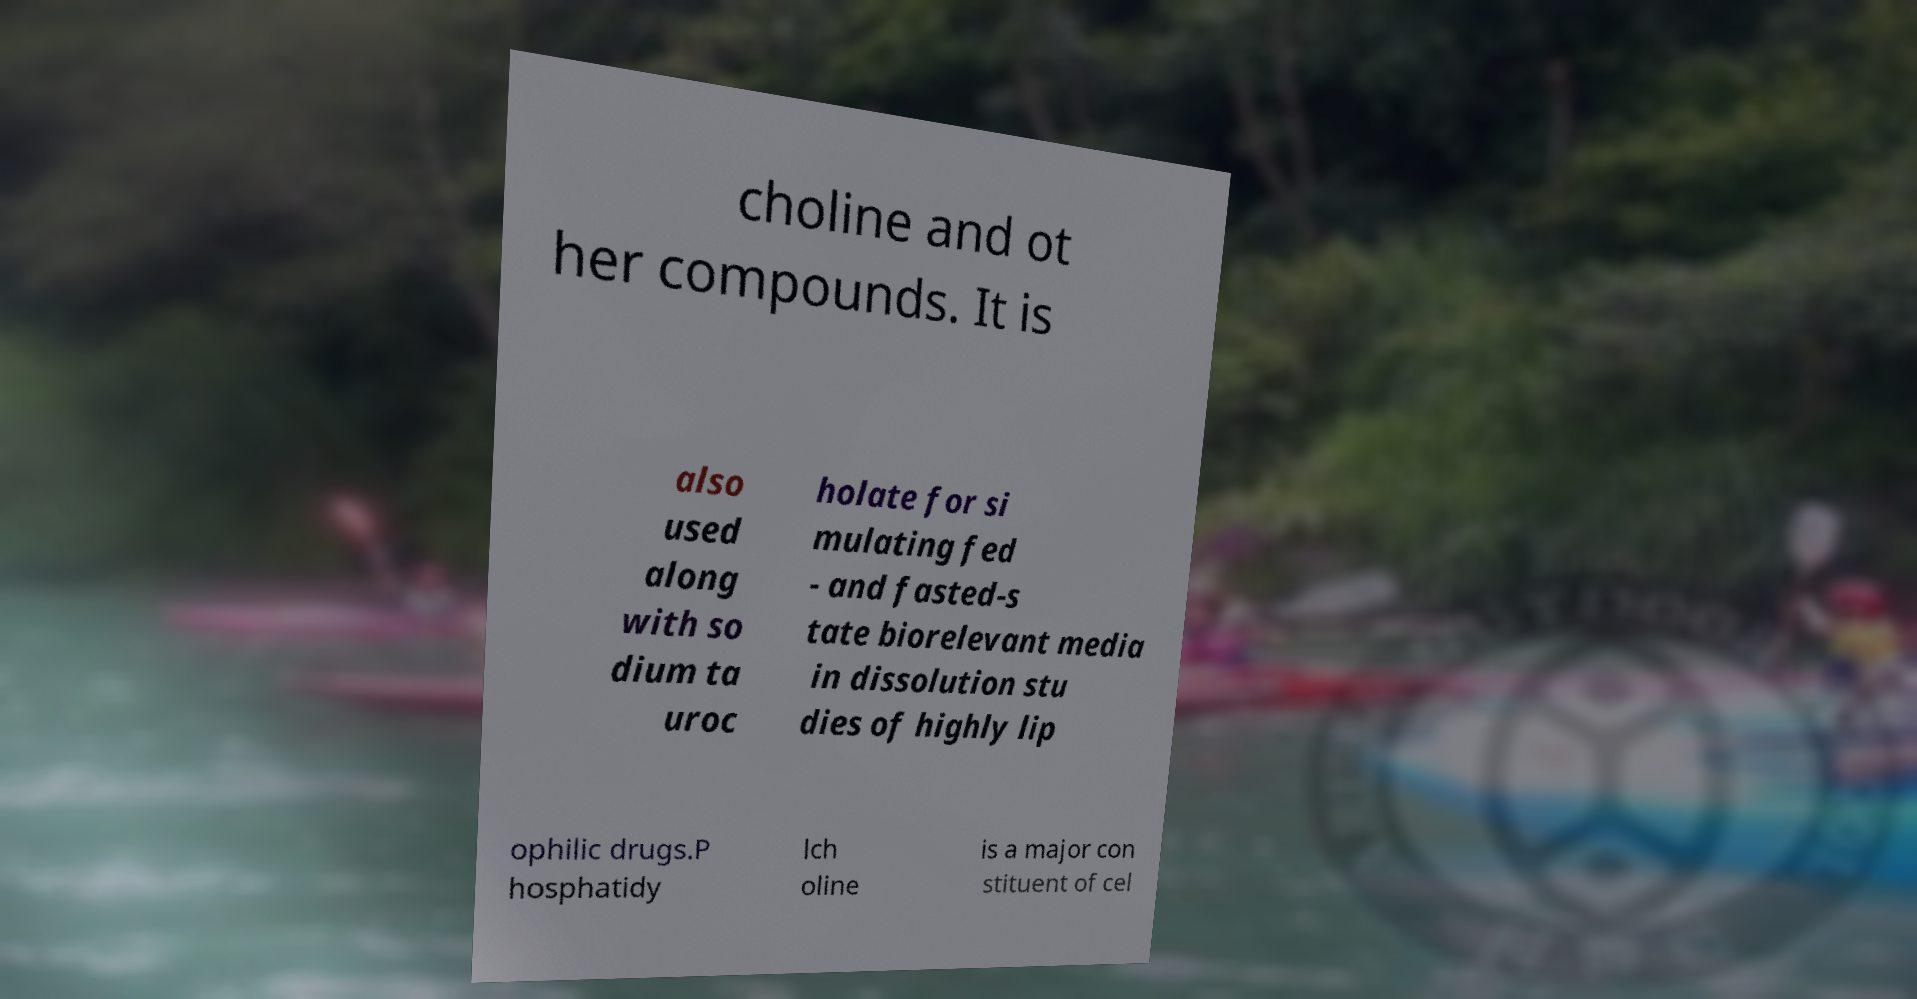Please read and relay the text visible in this image. What does it say? choline and ot her compounds. It is also used along with so dium ta uroc holate for si mulating fed - and fasted-s tate biorelevant media in dissolution stu dies of highly lip ophilic drugs.P hosphatidy lch oline is a major con stituent of cel 